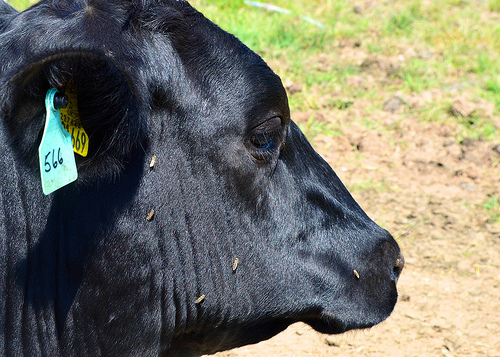<image>
Is there a cow on the ground? Yes. Looking at the image, I can see the cow is positioned on top of the ground, with the ground providing support. 